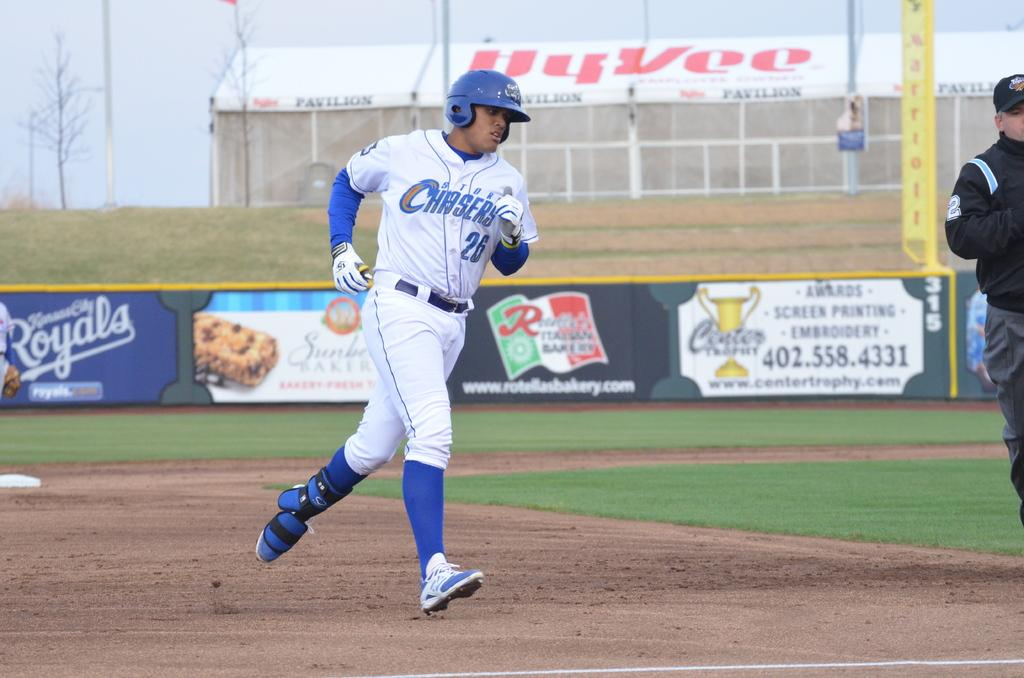<image>
Give a short and clear explanation of the subsequent image. Baseball player running the bases with storm chasers on the front of his uniform. 